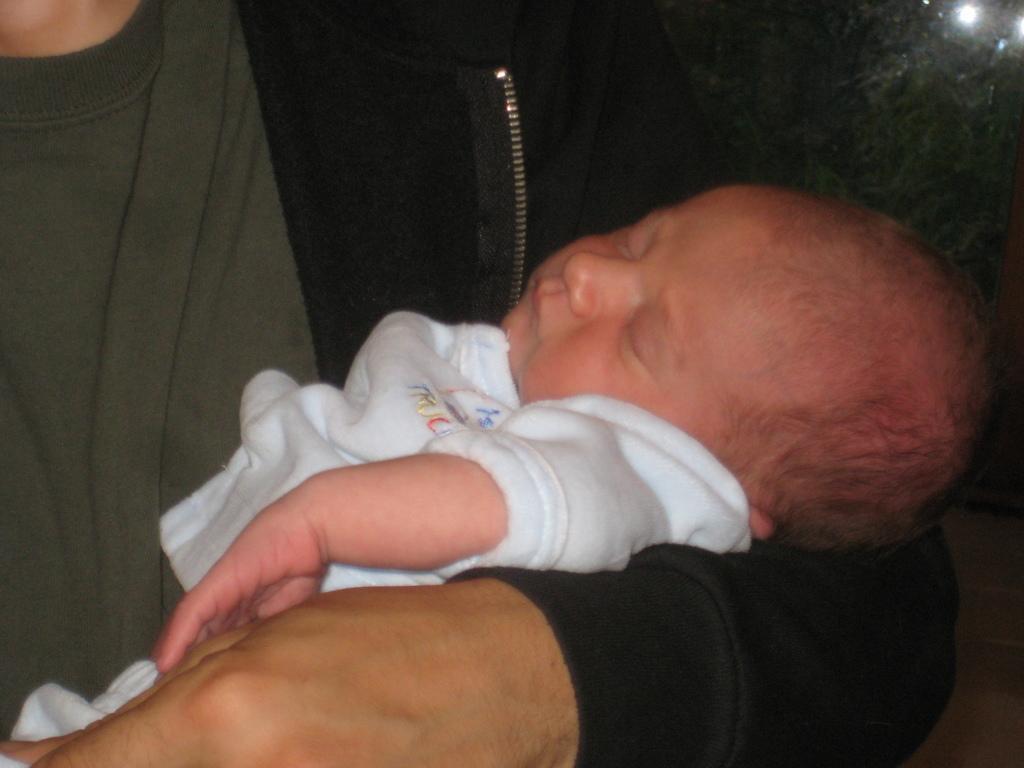Can you describe this image briefly? In this picture we can see a person is holding a baby. Behind the person, there is the dark background. 